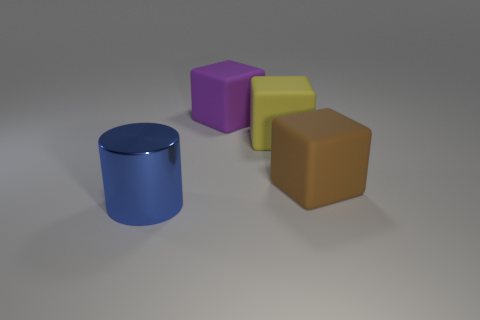Add 3 brown matte objects. How many objects exist? 7 Subtract all cylinders. How many objects are left? 3 Subtract 0 yellow cylinders. How many objects are left? 4 Subtract all large green shiny things. Subtract all large objects. How many objects are left? 0 Add 1 metal objects. How many metal objects are left? 2 Add 2 large rubber things. How many large rubber things exist? 5 